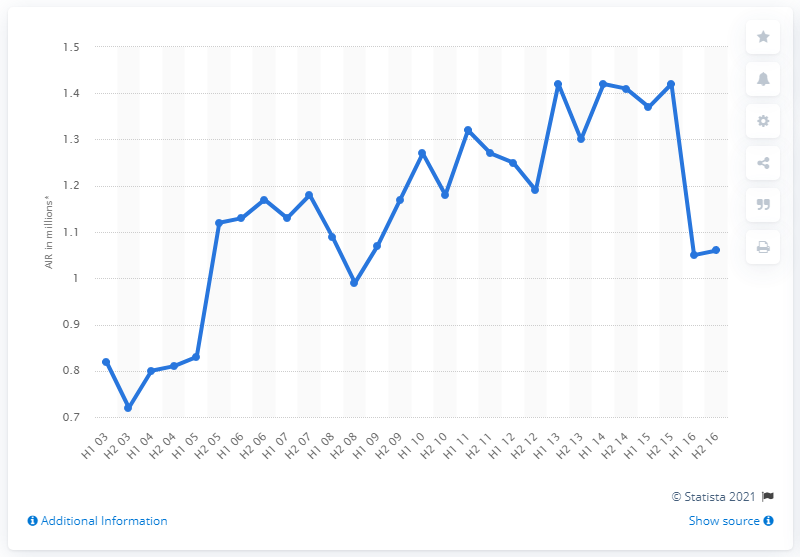Mention a couple of crucial points in this snapshot. In the second half of 2015, the average number of readers per issue of BBC Good Food magazine was 1.41. 